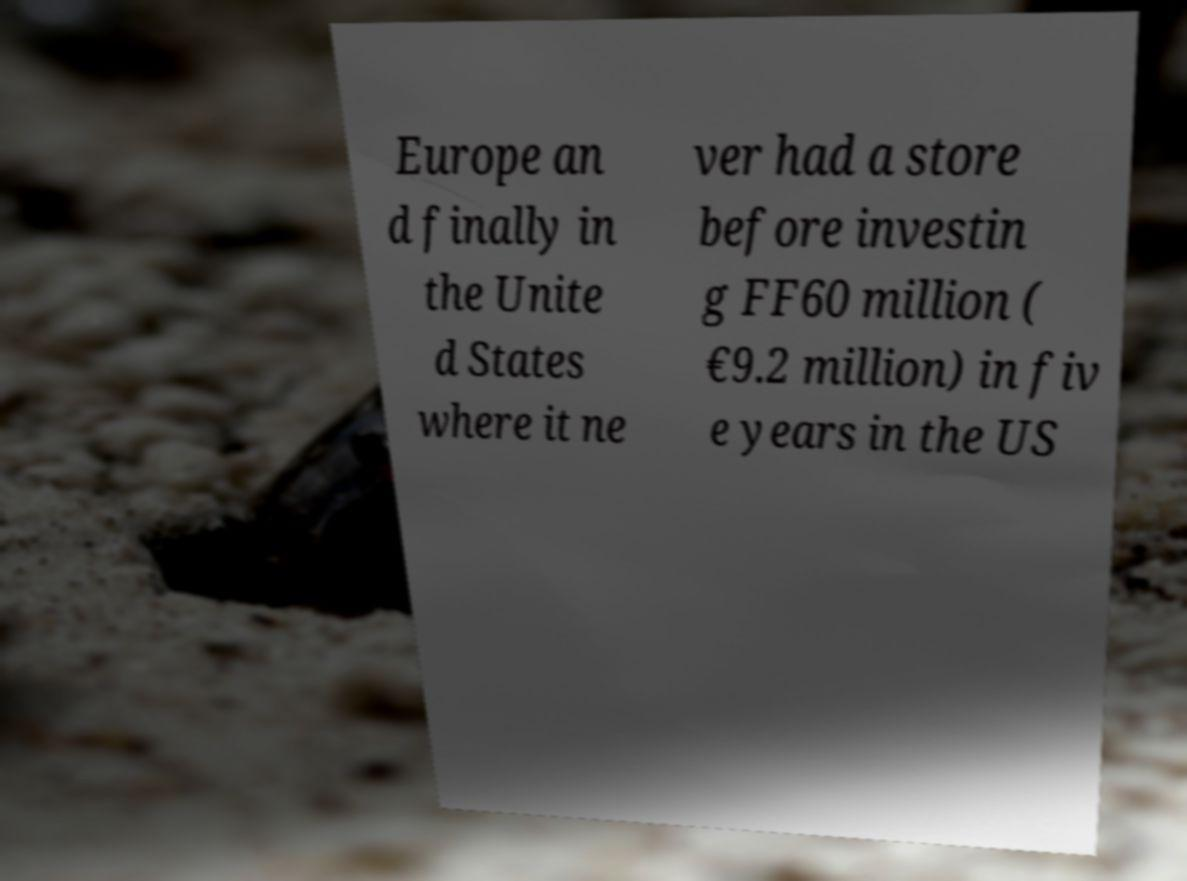I need the written content from this picture converted into text. Can you do that? Europe an d finally in the Unite d States where it ne ver had a store before investin g FF60 million ( €9.2 million) in fiv e years in the US 